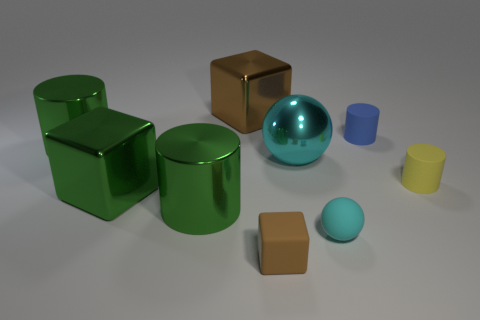What shape is the big shiny object that is the same color as the small rubber sphere?
Your answer should be very brief. Sphere. There is another cylinder that is the same material as the tiny yellow cylinder; what is its size?
Your response must be concise. Small. Are there any small cylinders that have the same color as the shiny ball?
Provide a short and direct response. No. Does the small object that is right of the tiny blue rubber object have the same color as the ball behind the small cyan sphere?
Your answer should be very brief. No. What is the size of the thing that is the same color as the tiny sphere?
Your answer should be very brief. Large. Is there a cylinder made of the same material as the big cyan object?
Offer a very short reply. Yes. The tiny rubber sphere has what color?
Your response must be concise. Cyan. What is the size of the green metallic cylinder that is in front of the large cube in front of the shiny object behind the blue matte cylinder?
Ensure brevity in your answer.  Large. How many other objects are the same shape as the yellow thing?
Your response must be concise. 3. What color is the cylinder that is both behind the yellow cylinder and in front of the blue cylinder?
Ensure brevity in your answer.  Green. 